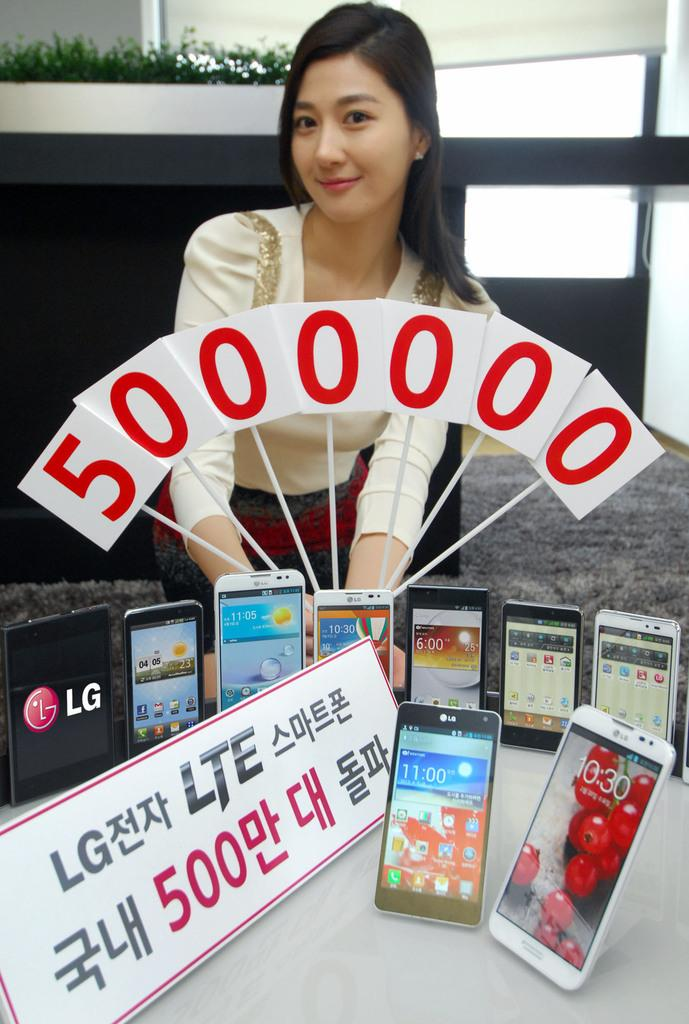<image>
Create a compact narrative representing the image presented. the number 500 is on an ad next to the lady 